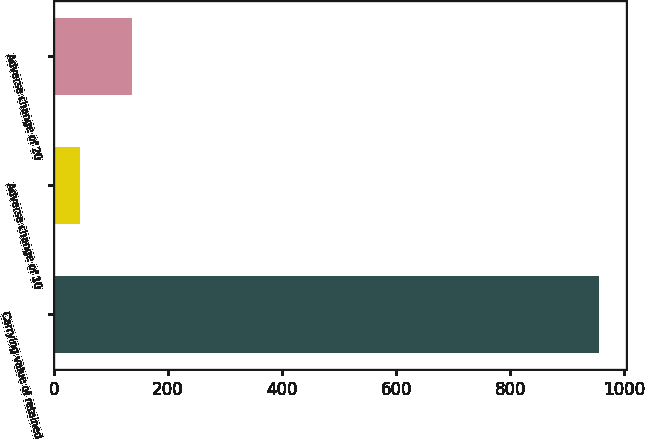Convert chart. <chart><loc_0><loc_0><loc_500><loc_500><bar_chart><fcel>Carrying value of retained<fcel>Adverse change of 10<fcel>Adverse change of 20<nl><fcel>956<fcel>45<fcel>136.1<nl></chart> 